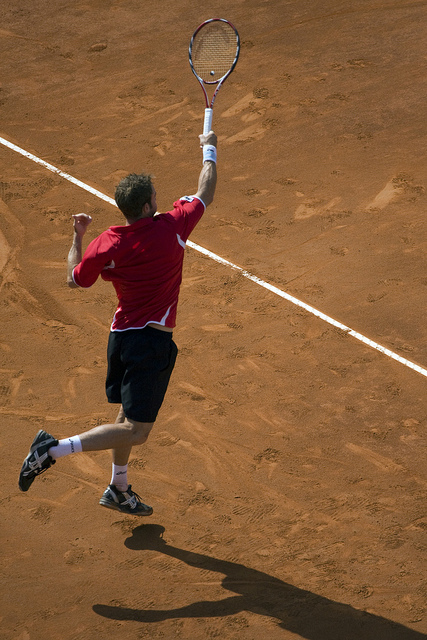<image>What brand is the tennis racket? I am unsure about the brand of the tennis racket. It could be Wilson, Nike, or Adidas. What brand is the tennis racket? I don't know what brand is the tennis racket. It can be either Wilson, Nike, Prince, or Adidas. 